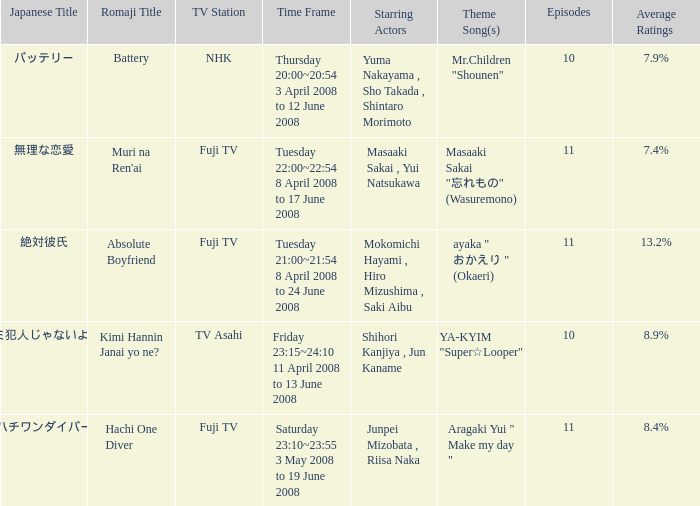How many titles had an average rating of 8.9%? 1.0. 